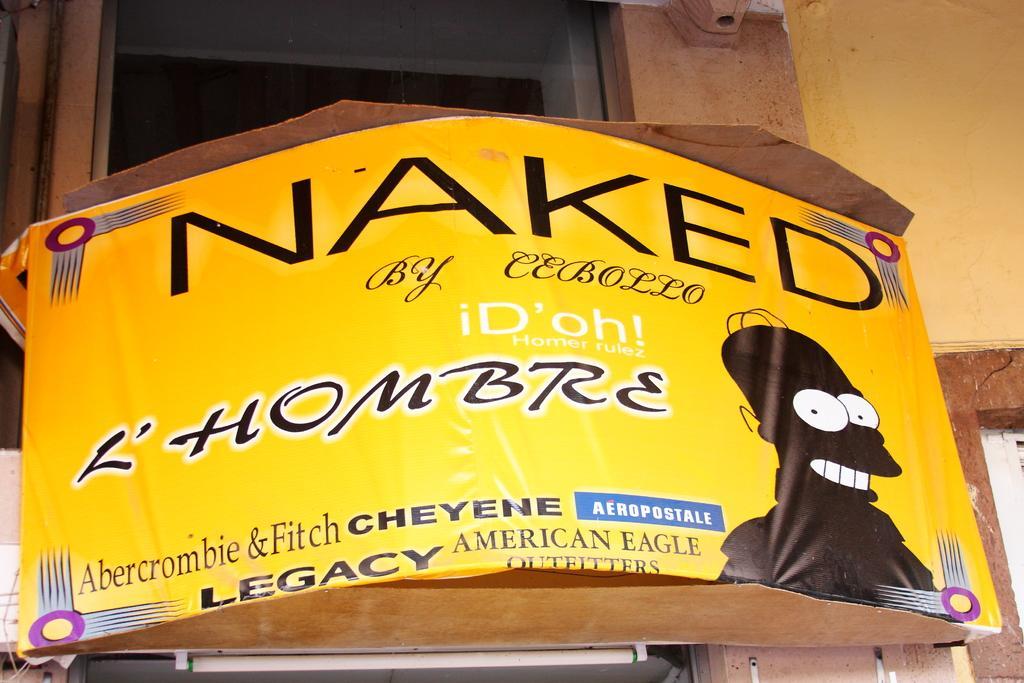Could you give a brief overview of what you see in this image? In this image there is a barrel which is in the center and some text is written on it. On the top there is a window and on the right side there is a wall 